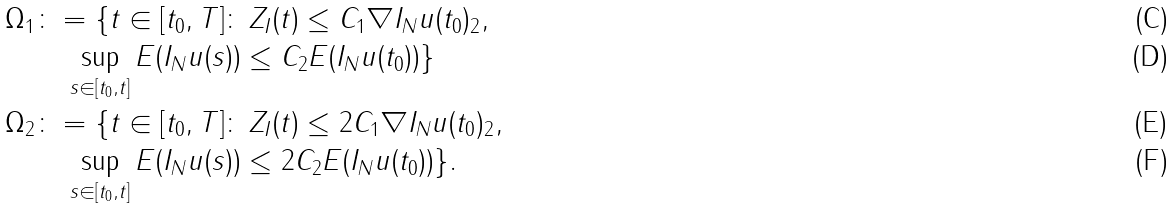<formula> <loc_0><loc_0><loc_500><loc_500>\Omega _ { 1 } & \colon = \{ t \in [ t _ { 0 } , T ] \colon \, Z _ { I } ( t ) \leq C _ { 1 } \| \nabla I _ { N } u ( t _ { 0 } ) \| _ { 2 } , \\ & \quad \sup _ { s \in [ t _ { 0 } , t ] } E ( I _ { N } u ( s ) ) \leq C _ { 2 } E ( I _ { N } u ( t _ { 0 } ) ) \} \\ \Omega _ { 2 } & \colon = \{ t \in [ t _ { 0 } , T ] \colon \, Z _ { I } ( t ) \leq 2 C _ { 1 } \| \nabla I _ { N } u ( t _ { 0 } ) \| _ { 2 } , \\ & \quad \sup _ { s \in [ t _ { 0 } , t ] } E ( I _ { N } u ( s ) ) \leq 2 C _ { 2 } E ( I _ { N } u ( t _ { 0 } ) ) \} .</formula> 